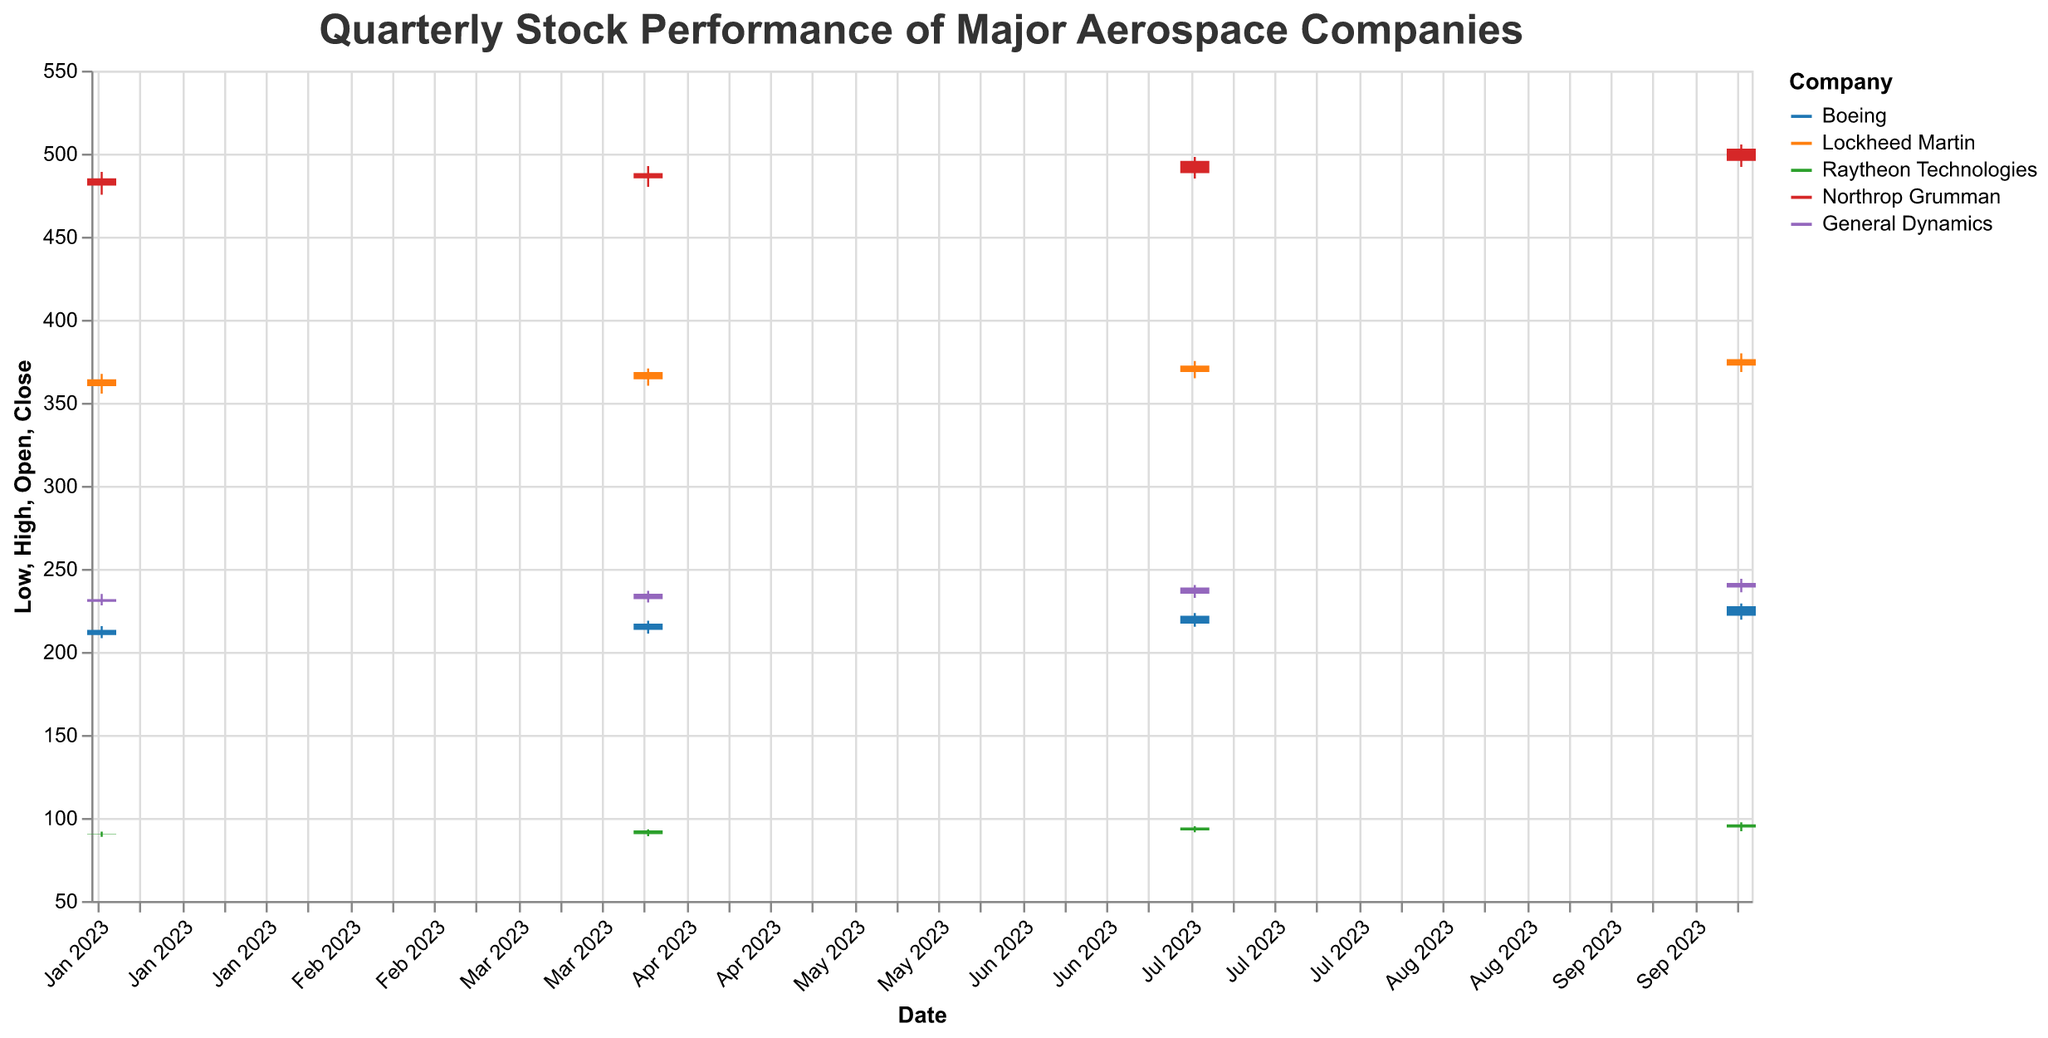What is the title of the figure? The title of the figure is located at the top and is written in a larger font size. It reads "Quarterly Stock Performance of Major Aerospace Companies."
Answer: Quarterly Stock Performance of Major Aerospace Companies What are the colors representing each company in the plot? The colors distinguishing each company are indicated in the legend on the right side of the plot. Boeing is represented by a blue color, Lockheed Martin by an orange color, Raytheon Technologies by a green color, Northrop Grumman by a red color, and General Dynamics by a purple color.
Answer: Boeing: blue, Lockheed Martin: orange, Raytheon Technologies: green, Northrop Grumman: red, General Dynamics: purple Which company had the highest closing price in October 2023? In October 2023, Northrop Grumman had the highest closing price. This can be observed by looking at the Closing prices in the plot for October 2023 and identifying the highest one which corresponds to Northrop Grumman.
Answer: Northrop Grumman How did Boeing's stock price change from January to October 2023? To assess the change in Boeing's stock price, we examine the closing prices for January and October 2023. In January, the closing price was $213.30, and in October, it was $227.50. The difference is calculated as $227.50 - $213.30.
Answer: Increased by $14.20 Comparing the stock performance, which company showed the greatest increase in closing price from January to October 2023? We need to calculate the difference in the closing prices for each company from January to October 2023. The calculations are as follows:
- Boeing: $227.50 - $213.30 = $14.20
- Lockheed Martin: $376.20 - $364.10 = $12.10
- Raytheon Technologies: $96.10 - $90.30 = $5.80
- Northrop Grumman: $503.00 - $485.10 = $17.90
- General Dynamics: $241.50 - $231.80 = $9.70
Northrop Grumman showed the greatest increase.
Answer: Northrop Grumman What does the vertical line (the "wick") in the candlestick plot represent? The vertical line, also known as the wick, represents the range between the highest and lowest prices of the stock for that specific date.
Answer: Range between high and low prices Which company had the highest trading volume in October 2023? The highest trading volume in October 2023 can be identified by checking the volumes listed for that month. Boeing had the highest volume with 6,300,000 shares traded.
Answer: Boeing Which company had the smallest range of stock prices in April 2023? To determine the smallest range, we calculate the difference between the high and low prices for each company in April 2023:
- Boeing: $218.70 - $211.00 = $7.70
- Lockheed Martin: $370.60 - $360.30 = $10.30
- Raytheon Technologies: $93.10 - $89.00 = $4.10
- Northrop Grumman: $492.50 - $480.00 = $12.50
- General Dynamics: $236.80 - $229.70 = $7.10
Raytheon Technologies had the smallest range.
Answer: Raytheon Technologies 